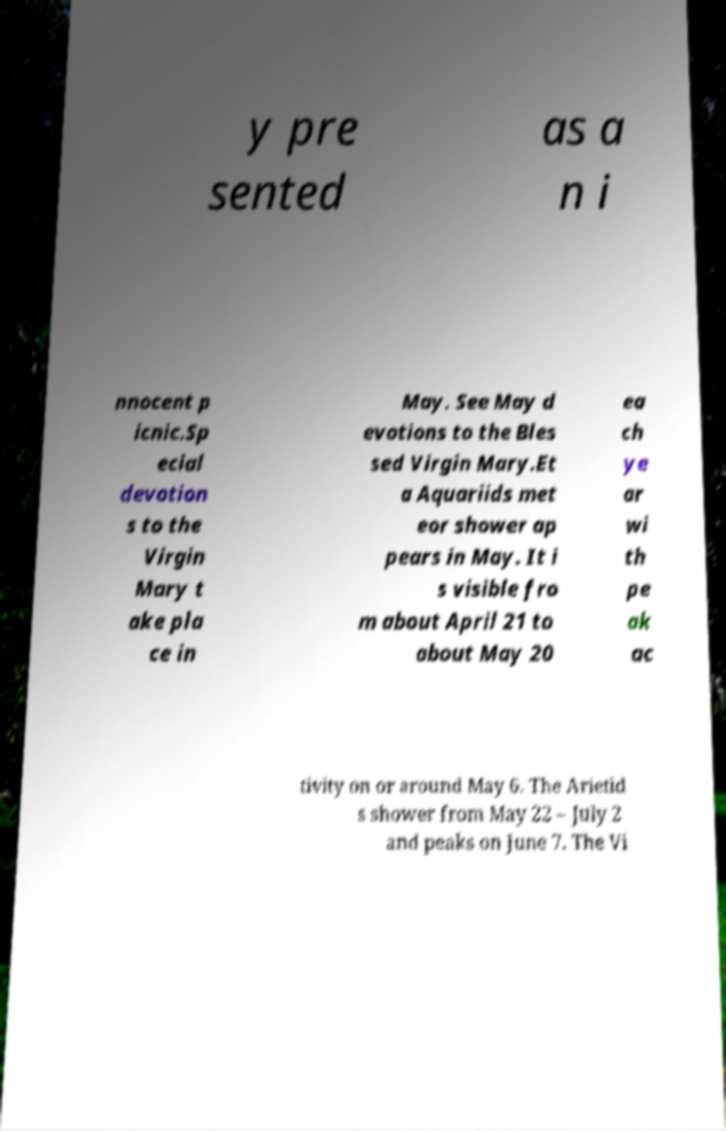Can you accurately transcribe the text from the provided image for me? y pre sented as a n i nnocent p icnic.Sp ecial devotion s to the Virgin Mary t ake pla ce in May. See May d evotions to the Bles sed Virgin Mary.Et a Aquariids met eor shower ap pears in May. It i s visible fro m about April 21 to about May 20 ea ch ye ar wi th pe ak ac tivity on or around May 6. The Arietid s shower from May 22 – July 2 and peaks on June 7. The Vi 